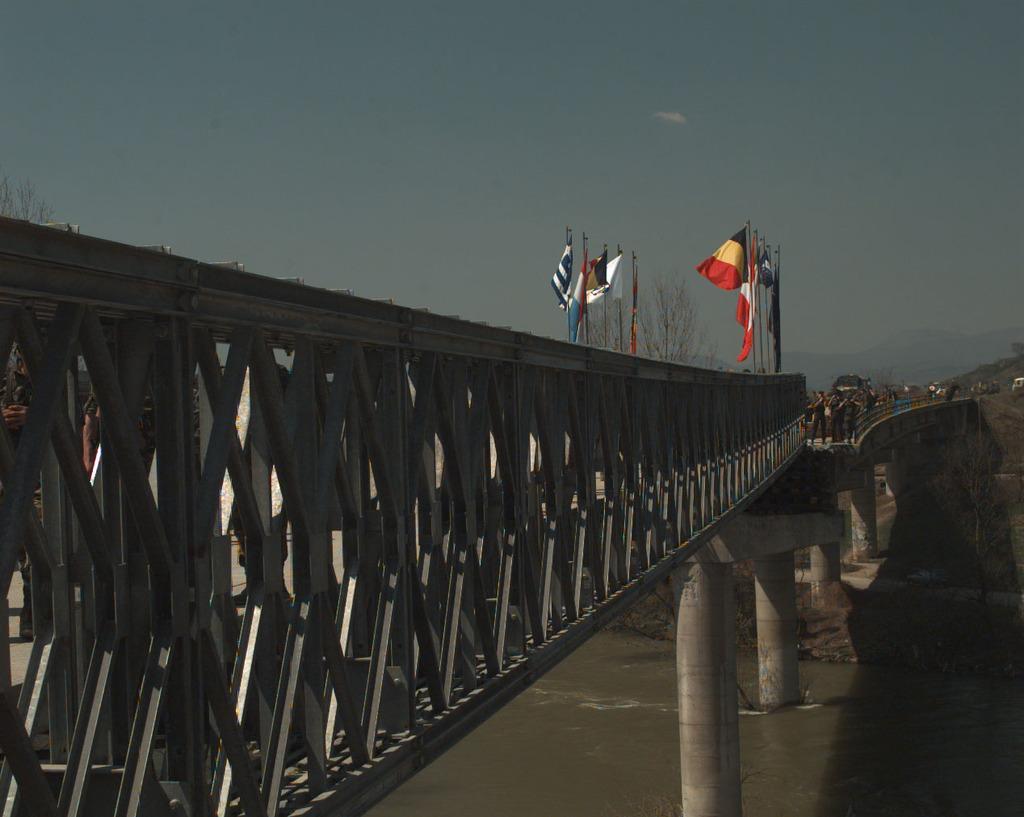Describe this image in one or two sentences. In this picture we can see water at the bottom, on the left side there is a bridge, we can see flags, trees and some people in the background, there is the sky at the top of the picture. 